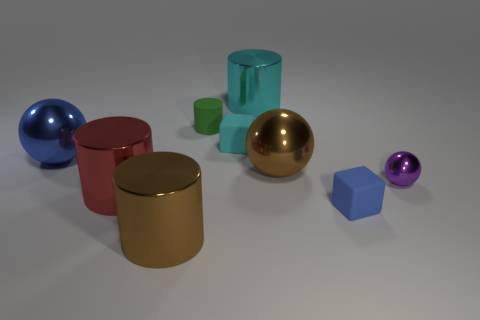Subtract all blue cubes. How many cubes are left? 1 Subtract all big balls. How many balls are left? 1 Subtract 1 brown balls. How many objects are left? 8 Subtract all spheres. How many objects are left? 6 Subtract 1 blocks. How many blocks are left? 1 Subtract all brown blocks. Subtract all cyan spheres. How many blocks are left? 2 Subtract all green spheres. How many yellow cylinders are left? 0 Subtract all rubber cylinders. Subtract all large brown cylinders. How many objects are left? 7 Add 7 purple spheres. How many purple spheres are left? 8 Add 5 small metal balls. How many small metal balls exist? 6 